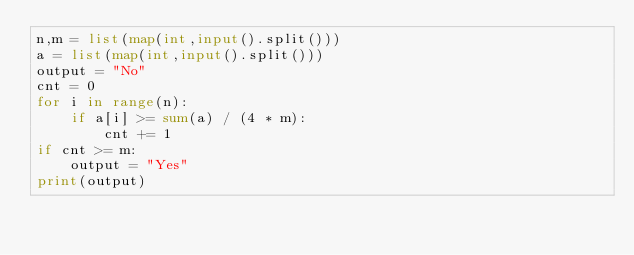<code> <loc_0><loc_0><loc_500><loc_500><_Python_>n,m = list(map(int,input().split()))
a = list(map(int,input().split()))
output = "No"
cnt = 0
for i in range(n):
    if a[i] >= sum(a) / (4 * m):
        cnt += 1
if cnt >= m:
    output = "Yes"
print(output)</code> 